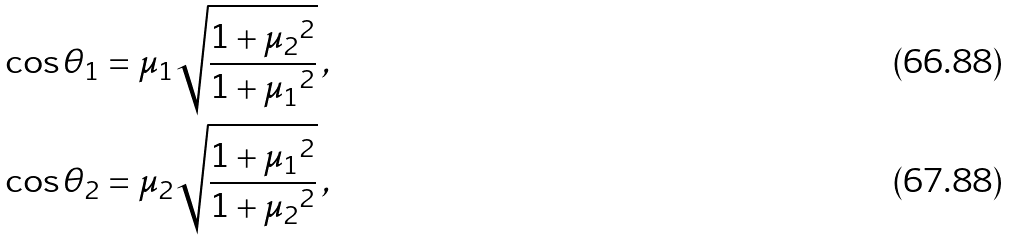<formula> <loc_0><loc_0><loc_500><loc_500>\cos \theta _ { 1 } & = \mu _ { 1 } \sqrt { \frac { 1 + { \mu _ { 2 } } ^ { 2 } } { 1 + { \mu _ { 1 } } ^ { 2 } } } \, , \\ \cos \theta _ { 2 } & = { \mu _ { 2 } } \sqrt { \frac { 1 + { \mu _ { 1 } } ^ { 2 } } { 1 + { \mu _ { 2 } } ^ { 2 } } } \, ,</formula> 